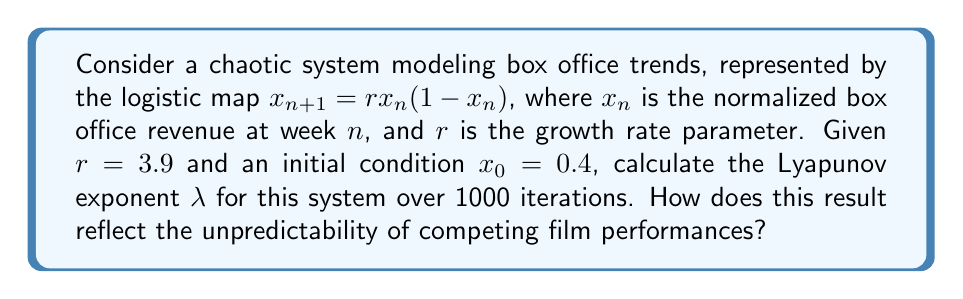What is the answer to this math problem? To calculate the Lyapunov exponent for this system:

1) The Lyapunov exponent is given by:
   $$\lambda = \lim_{N \to \infty} \frac{1}{N} \sum_{n=0}^{N-1} \ln |f'(x_n)|$$

2) For the logistic map, $f(x) = rx(1-x)$, so $f'(x) = r(1-2x)$

3) Implement the iteration:
   $$x_{n+1} = 3.9x_n(1-x_n)$$

4) Calculate the sum:
   $$S = \sum_{n=0}^{999} \ln |3.9(1-2x_n)|$$

5) Using a computer or calculator:
   - Generate 1000 iterations of $x_n$
   - Calculate $\ln |3.9(1-2x_n)|$ for each $x_n$
   - Sum these values

6) After computation, we find $S \approx 579.3$

7) Calculate $\lambda$:
   $$\lambda \approx \frac{579.3}{1000} \approx 0.5793$$

The positive Lyapunov exponent indicates chaos in the system, reflecting highly unpredictable box office trends. This unpredictability makes it challenging for competing curators to anticipate audience preferences, as small changes in initial conditions can lead to vastly different outcomes over time.
Answer: $\lambda \approx 0.5793$ 